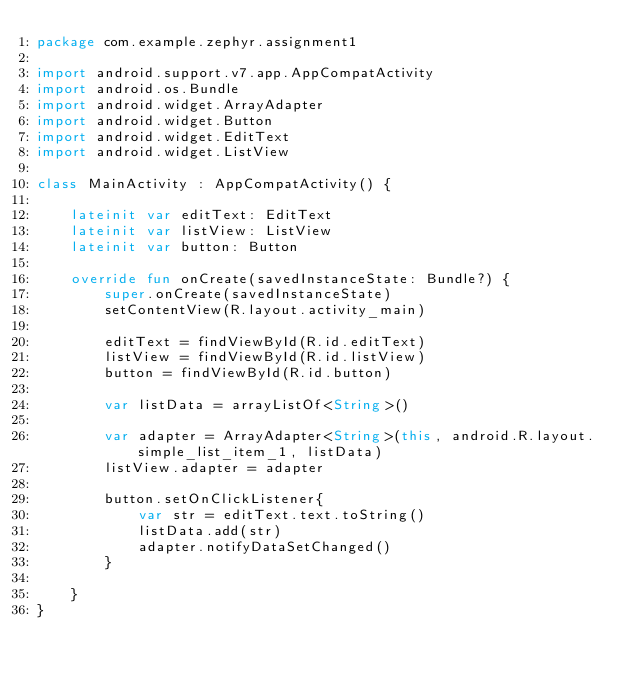<code> <loc_0><loc_0><loc_500><loc_500><_Kotlin_>package com.example.zephyr.assignment1

import android.support.v7.app.AppCompatActivity
import android.os.Bundle
import android.widget.ArrayAdapter
import android.widget.Button
import android.widget.EditText
import android.widget.ListView

class MainActivity : AppCompatActivity() {

    lateinit var editText: EditText
    lateinit var listView: ListView
    lateinit var button: Button

    override fun onCreate(savedInstanceState: Bundle?) {
        super.onCreate(savedInstanceState)
        setContentView(R.layout.activity_main)

        editText = findViewById(R.id.editText)
        listView = findViewById(R.id.listView)
        button = findViewById(R.id.button)

        var listData = arrayListOf<String>()

        var adapter = ArrayAdapter<String>(this, android.R.layout.simple_list_item_1, listData)
        listView.adapter = adapter

        button.setOnClickListener{
            var str = editText.text.toString()
            listData.add(str)
            adapter.notifyDataSetChanged()
        }

    }
}
</code> 